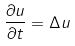Convert formula to latex. <formula><loc_0><loc_0><loc_500><loc_500>\frac { \partial u } { \partial t } = \Delta u</formula> 